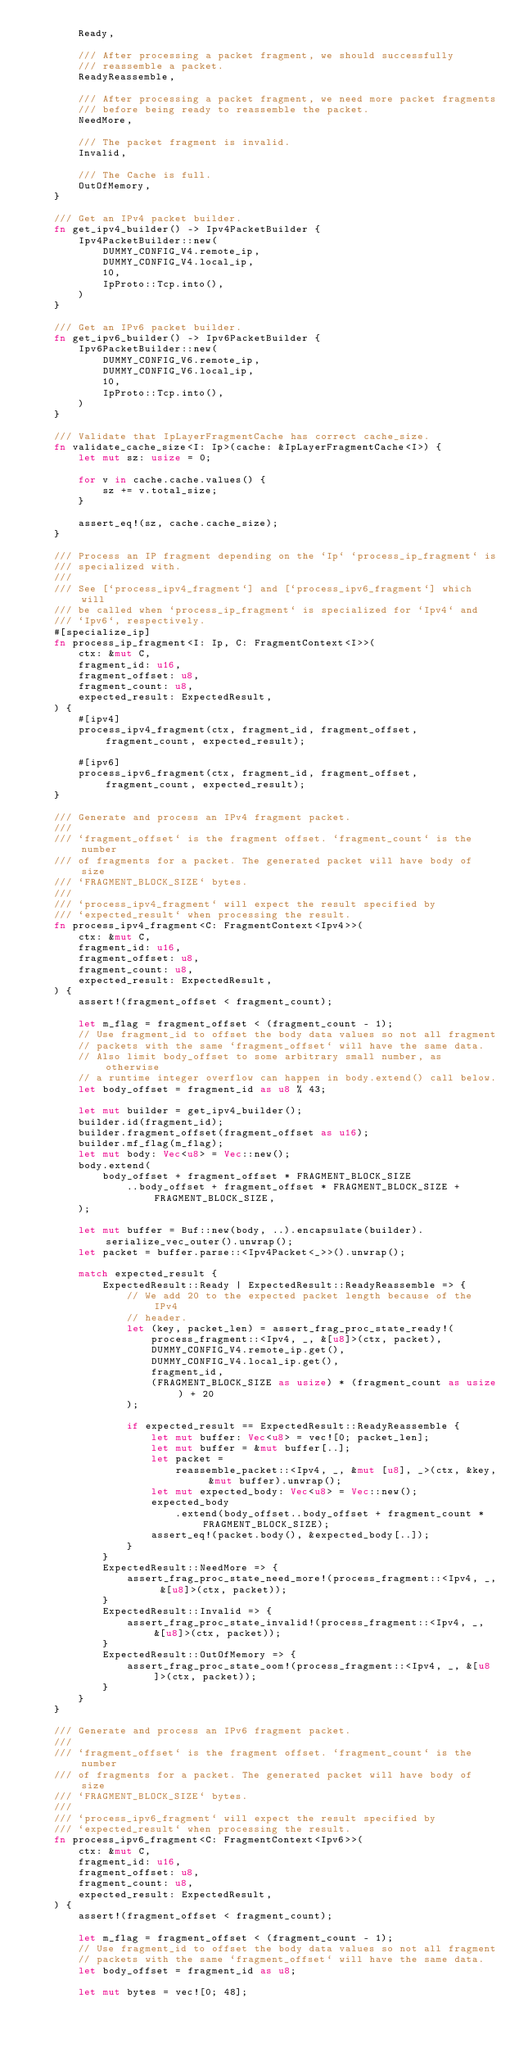<code> <loc_0><loc_0><loc_500><loc_500><_Rust_>        Ready,

        /// After processing a packet fragment, we should successfully
        /// reassemble a packet.
        ReadyReassemble,

        /// After processing a packet fragment, we need more packet fragments
        /// before being ready to reassemble the packet.
        NeedMore,

        /// The packet fragment is invalid.
        Invalid,

        /// The Cache is full.
        OutOfMemory,
    }

    /// Get an IPv4 packet builder.
    fn get_ipv4_builder() -> Ipv4PacketBuilder {
        Ipv4PacketBuilder::new(
            DUMMY_CONFIG_V4.remote_ip,
            DUMMY_CONFIG_V4.local_ip,
            10,
            IpProto::Tcp.into(),
        )
    }

    /// Get an IPv6 packet builder.
    fn get_ipv6_builder() -> Ipv6PacketBuilder {
        Ipv6PacketBuilder::new(
            DUMMY_CONFIG_V6.remote_ip,
            DUMMY_CONFIG_V6.local_ip,
            10,
            IpProto::Tcp.into(),
        )
    }

    /// Validate that IpLayerFragmentCache has correct cache_size.
    fn validate_cache_size<I: Ip>(cache: &IpLayerFragmentCache<I>) {
        let mut sz: usize = 0;

        for v in cache.cache.values() {
            sz += v.total_size;
        }

        assert_eq!(sz, cache.cache_size);
    }

    /// Process an IP fragment depending on the `Ip` `process_ip_fragment` is
    /// specialized with.
    ///
    /// See [`process_ipv4_fragment`] and [`process_ipv6_fragment`] which will
    /// be called when `process_ip_fragment` is specialized for `Ipv4` and
    /// `Ipv6`, respectively.
    #[specialize_ip]
    fn process_ip_fragment<I: Ip, C: FragmentContext<I>>(
        ctx: &mut C,
        fragment_id: u16,
        fragment_offset: u8,
        fragment_count: u8,
        expected_result: ExpectedResult,
    ) {
        #[ipv4]
        process_ipv4_fragment(ctx, fragment_id, fragment_offset, fragment_count, expected_result);

        #[ipv6]
        process_ipv6_fragment(ctx, fragment_id, fragment_offset, fragment_count, expected_result);
    }

    /// Generate and process an IPv4 fragment packet.
    ///
    /// `fragment_offset` is the fragment offset. `fragment_count` is the number
    /// of fragments for a packet. The generated packet will have body of size
    /// `FRAGMENT_BLOCK_SIZE` bytes.
    ///
    /// `process_ipv4_fragment` will expect the result specified by
    /// `expected_result` when processing the result.
    fn process_ipv4_fragment<C: FragmentContext<Ipv4>>(
        ctx: &mut C,
        fragment_id: u16,
        fragment_offset: u8,
        fragment_count: u8,
        expected_result: ExpectedResult,
    ) {
        assert!(fragment_offset < fragment_count);

        let m_flag = fragment_offset < (fragment_count - 1);
        // Use fragment_id to offset the body data values so not all fragment
        // packets with the same `fragment_offset` will have the same data.
        // Also limit body_offset to some arbitrary small number, as otherwise
        // a runtime integer overflow can happen in body.extend() call below.
        let body_offset = fragment_id as u8 % 43;

        let mut builder = get_ipv4_builder();
        builder.id(fragment_id);
        builder.fragment_offset(fragment_offset as u16);
        builder.mf_flag(m_flag);
        let mut body: Vec<u8> = Vec::new();
        body.extend(
            body_offset + fragment_offset * FRAGMENT_BLOCK_SIZE
                ..body_offset + fragment_offset * FRAGMENT_BLOCK_SIZE + FRAGMENT_BLOCK_SIZE,
        );

        let mut buffer = Buf::new(body, ..).encapsulate(builder).serialize_vec_outer().unwrap();
        let packet = buffer.parse::<Ipv4Packet<_>>().unwrap();

        match expected_result {
            ExpectedResult::Ready | ExpectedResult::ReadyReassemble => {
                // We add 20 to the expected packet length because of the IPv4
                // header.
                let (key, packet_len) = assert_frag_proc_state_ready!(
                    process_fragment::<Ipv4, _, &[u8]>(ctx, packet),
                    DUMMY_CONFIG_V4.remote_ip.get(),
                    DUMMY_CONFIG_V4.local_ip.get(),
                    fragment_id,
                    (FRAGMENT_BLOCK_SIZE as usize) * (fragment_count as usize) + 20
                );

                if expected_result == ExpectedResult::ReadyReassemble {
                    let mut buffer: Vec<u8> = vec![0; packet_len];
                    let mut buffer = &mut buffer[..];
                    let packet =
                        reassemble_packet::<Ipv4, _, &mut [u8], _>(ctx, &key, &mut buffer).unwrap();
                    let mut expected_body: Vec<u8> = Vec::new();
                    expected_body
                        .extend(body_offset..body_offset + fragment_count * FRAGMENT_BLOCK_SIZE);
                    assert_eq!(packet.body(), &expected_body[..]);
                }
            }
            ExpectedResult::NeedMore => {
                assert_frag_proc_state_need_more!(process_fragment::<Ipv4, _, &[u8]>(ctx, packet));
            }
            ExpectedResult::Invalid => {
                assert_frag_proc_state_invalid!(process_fragment::<Ipv4, _, &[u8]>(ctx, packet));
            }
            ExpectedResult::OutOfMemory => {
                assert_frag_proc_state_oom!(process_fragment::<Ipv4, _, &[u8]>(ctx, packet));
            }
        }
    }

    /// Generate and process an IPv6 fragment packet.
    ///
    /// `fragment_offset` is the fragment offset. `fragment_count` is the number
    /// of fragments for a packet. The generated packet will have body of size
    /// `FRAGMENT_BLOCK_SIZE` bytes.
    ///
    /// `process_ipv6_fragment` will expect the result specified by
    /// `expected_result` when processing the result.
    fn process_ipv6_fragment<C: FragmentContext<Ipv6>>(
        ctx: &mut C,
        fragment_id: u16,
        fragment_offset: u8,
        fragment_count: u8,
        expected_result: ExpectedResult,
    ) {
        assert!(fragment_offset < fragment_count);

        let m_flag = fragment_offset < (fragment_count - 1);
        // Use fragment_id to offset the body data values so not all fragment
        // packets with the same `fragment_offset` will have the same data.
        let body_offset = fragment_id as u8;

        let mut bytes = vec![0; 48];</code> 